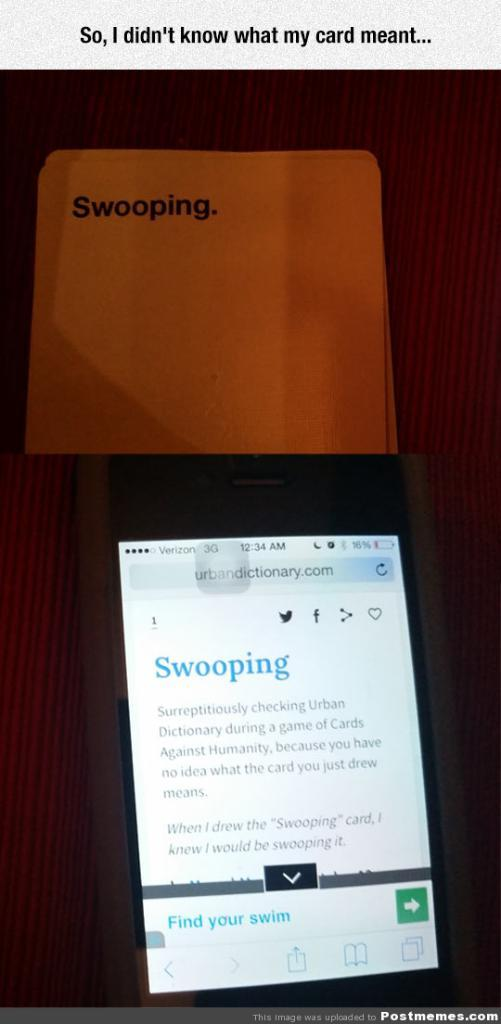<image>
Provide a brief description of the given image. A card game with the word swooping on it is shown behind a phone with the definition for the word swooping on its display. 